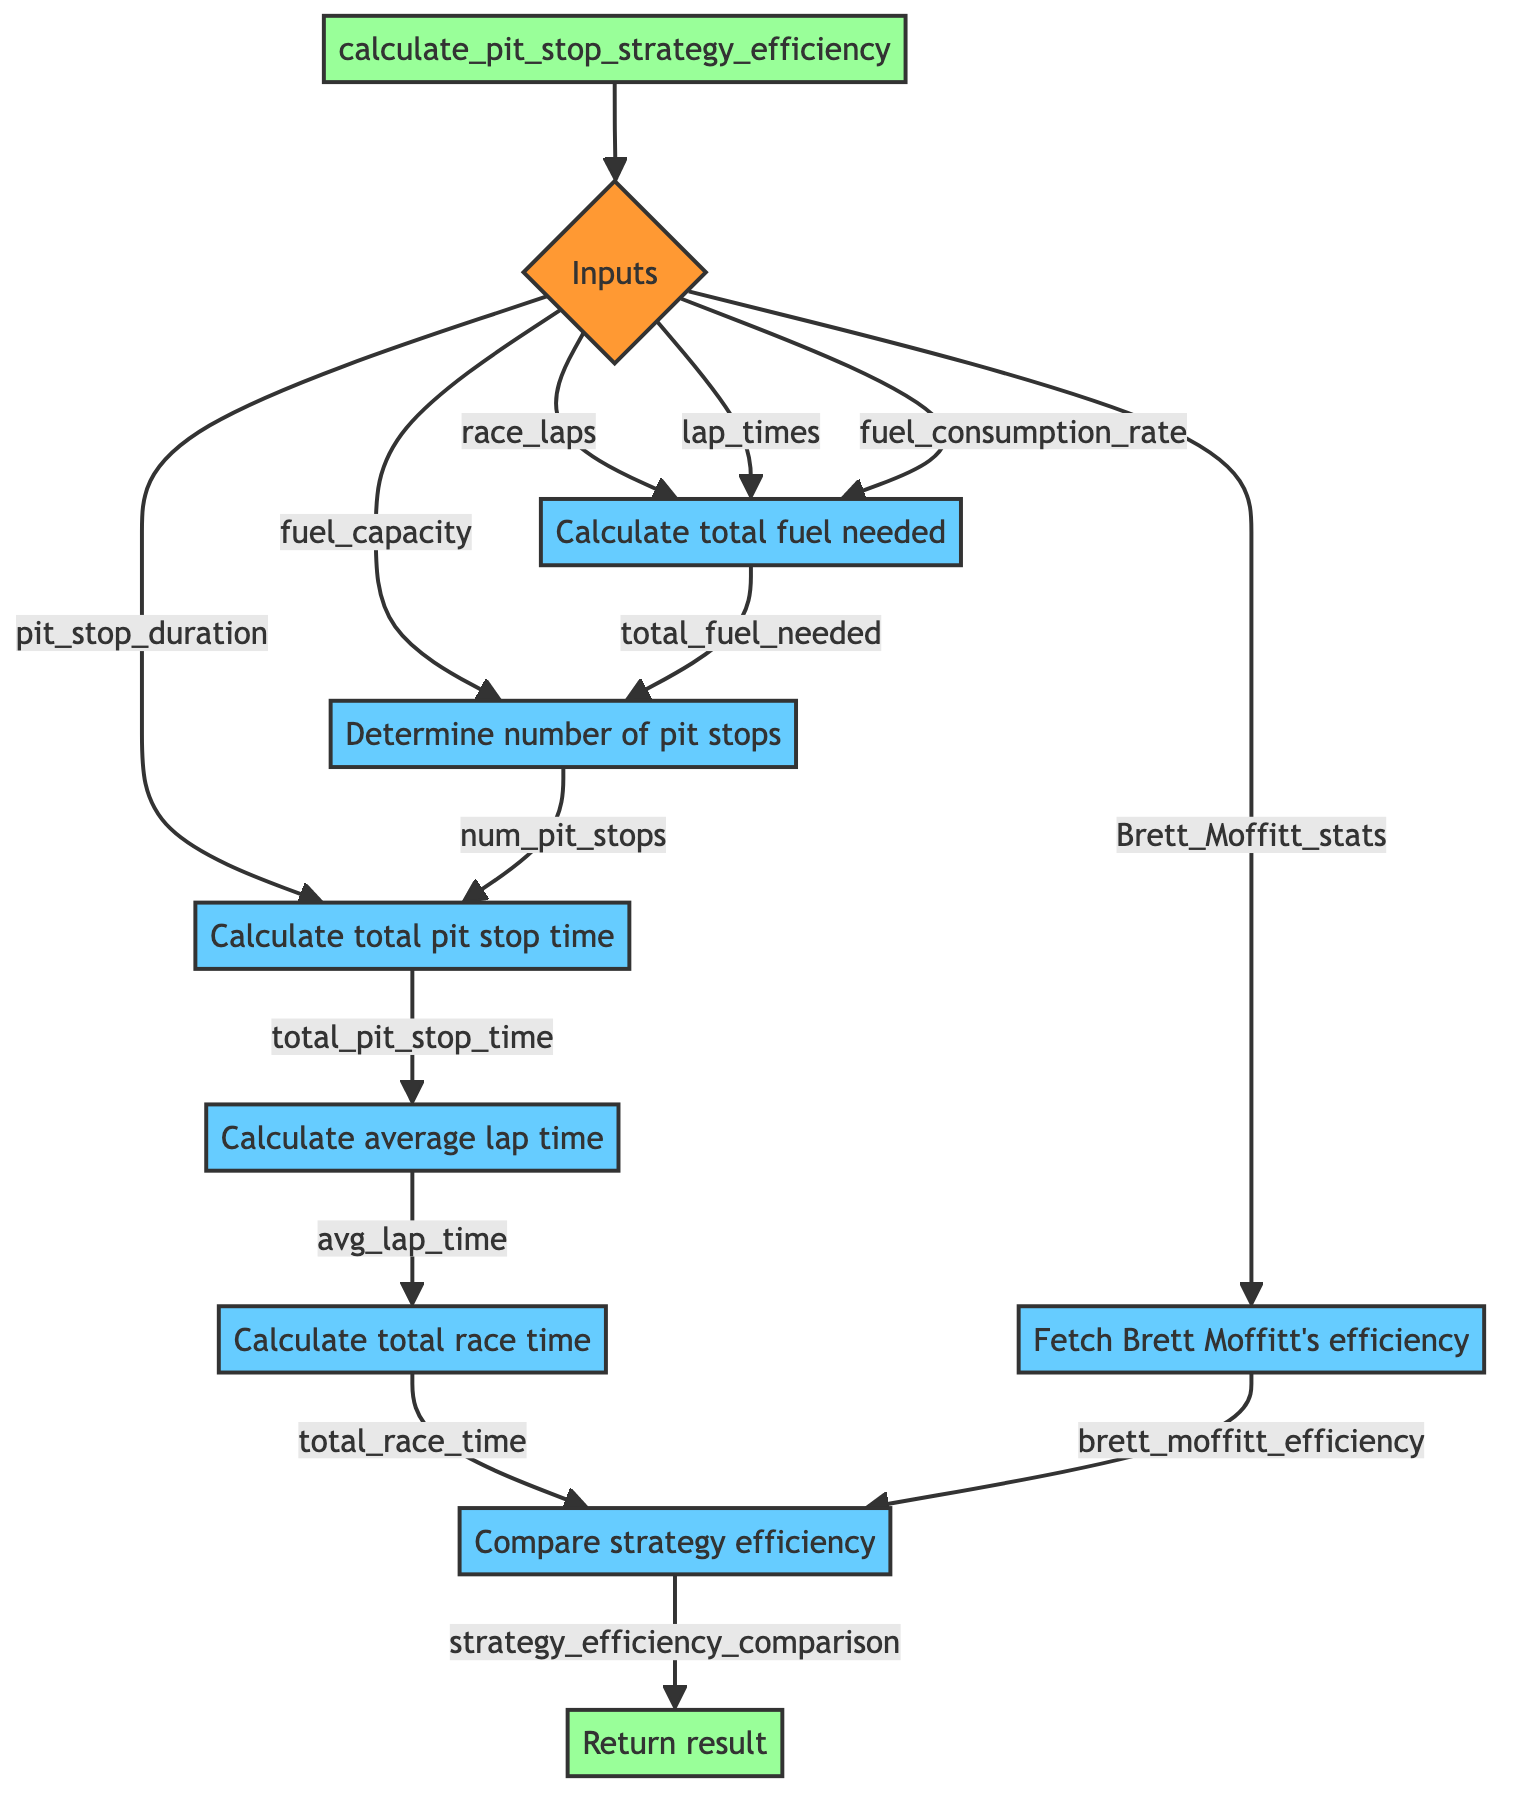what's the first input specified in the diagram? The first input specified in the diagram is "race_laps". It is directly connected to the "Inputs" node which denotes the different parameters needed for the function.
Answer: race_laps how many steps are involved in the process after "Calculate total fuel needed"? After "Calculate total fuel needed", there are four subsequent steps: "Determine number of pit stops required", "Calculate total time spent in pit stops", "Calculate average lap time excluding pit stop time", and "Calculate total race time". This indicates that there are four steps that follow.
Answer: four what operation calculates the total fuel needed for the race? The total fuel needed for the race is calculated by multiplying "race_laps" by "fuel_consumption_rate". This operation shows how much fuel is necessary given the number of laps and the rate at which fuel is consumed.
Answer: race_laps * fuel_consumption_rate what is the final output of the function? The final output of the function is "strategy_efficiency_comparison". After all operations are complete, this value is returned as the result indicating how the calculated pit stop strategy efficiency compares to Brett Moffitt's.
Answer: strategy_efficiency_comparison how is the number of pit stops determined? The number of pit stops is determined by taking the ceiling of the division of "total_fuel_needed" by "fuel_capacity". This step ensures that even if there is a remainder (indicating additional fuel is needed), an extra pit stop will be counted.
Answer: ceil(total_fuel_needed / fuel_capacity) what does the node "Fetch Brett Moffitt's historical pit stop efficiency" provide? The node "Fetch Brett Moffitt's historical pit stop efficiency" provides a variable called "brett_moffitt_efficiency". This variable is critical for comparing the computed race strategy's efficiency against the historical performance of Brett Moffitt.
Answer: brett_moffitt_efficiency what node follows after "Calculate total race time"? The node that follows after "Calculate total race time" is "Compare calculated pit stop strategy efficiency". This node uses the total race time and Brett Moffitt's efficiency for a comparative analysis of the pit stop strategy.
Answer: Compare calculated pit stop strategy efficiency how is average lap time calculated in the process? Average lap time is calculated by summing all the values in "lap_times" and then dividing by "race_laps". This gives an average duration per lap, excluding any time spent in pit stops.
Answer: sum(lap_times) / race_laps 